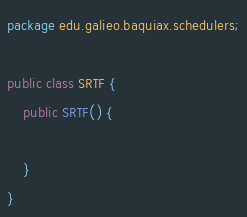Convert code to text. <code><loc_0><loc_0><loc_500><loc_500><_Java_>package edu.galieo.baquiax.schedulers;

public class SRTF {
    public SRTF() {
                   
    }
}</code> 